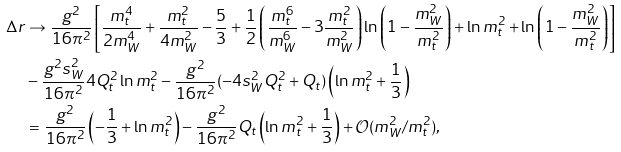Convert formula to latex. <formula><loc_0><loc_0><loc_500><loc_500>\Delta r & \to \frac { g ^ { 2 } } { 1 6 \pi ^ { 2 } } \left [ \frac { m _ { t } ^ { 4 } } { 2 m _ { W } ^ { 4 } } + \frac { m _ { t } ^ { 2 } } { 4 m _ { W } ^ { 2 } } - \frac { 5 } { 3 } + \frac { 1 } { 2 } \left ( \frac { m _ { t } ^ { 6 } } { m _ { W } ^ { 6 } } - 3 \frac { m _ { t } ^ { 2 } } { m _ { W } ^ { 2 } } \right ) \ln \left ( 1 - \frac { m _ { W } ^ { 2 } } { m _ { t } ^ { 2 } } \right ) + \ln m _ { t } ^ { 2 } + \ln \left ( 1 - \frac { m _ { W } ^ { 2 } } { m _ { t } ^ { 2 } } \right ) \right ] \\ & - \frac { g ^ { 2 } s _ { W } ^ { 2 } } { 1 6 \pi ^ { 2 } } 4 Q _ { t } ^ { 2 } \ln m _ { t } ^ { 2 } - \frac { g ^ { 2 } } { 1 6 \pi ^ { 2 } } ( - 4 s _ { W } ^ { 2 } Q _ { t } ^ { 2 } + Q _ { t } ) \left ( \ln m _ { t } ^ { 2 } + \frac { 1 } { 3 } \right ) \\ & = \frac { g ^ { 2 } } { 1 6 \pi ^ { 2 } } \left ( - \frac { 1 } { 3 } + \ln m _ { t } ^ { 2 } \right ) - \frac { g ^ { 2 } } { 1 6 \pi ^ { 2 } } Q _ { t } \left ( \ln m _ { t } ^ { 2 } + \frac { 1 } { 3 } \right ) + \mathcal { O } ( m _ { W } ^ { 2 } / m _ { t } ^ { 2 } ) ,</formula> 